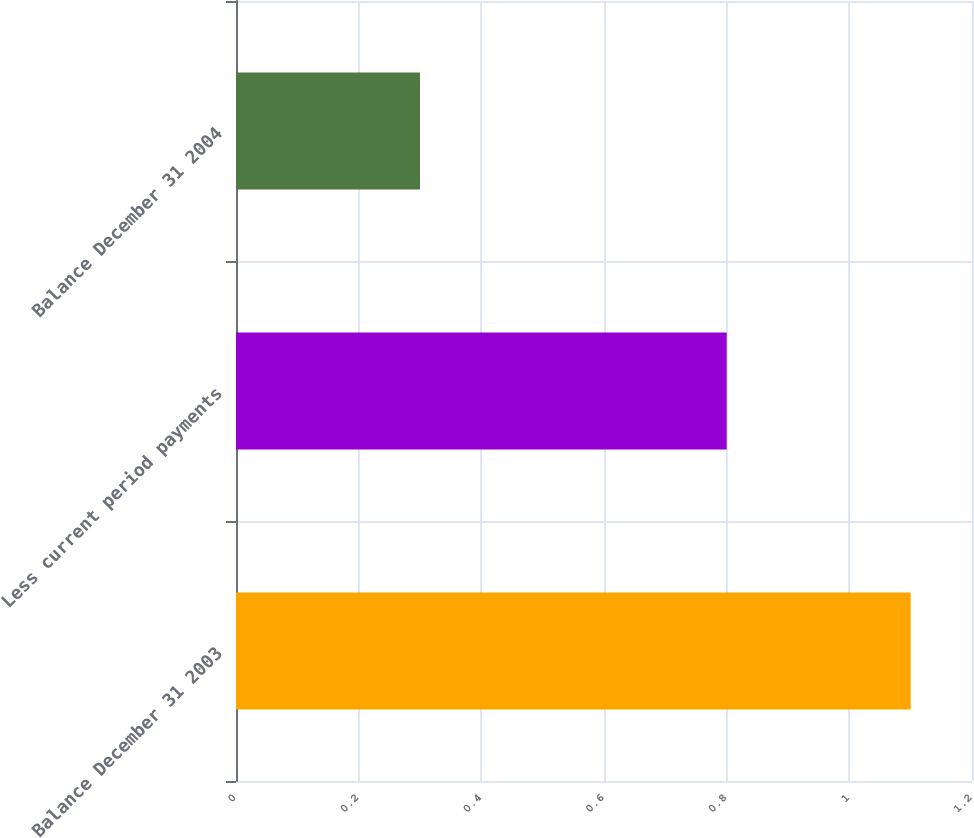Convert chart to OTSL. <chart><loc_0><loc_0><loc_500><loc_500><bar_chart><fcel>Balance December 31 2003<fcel>Less current period payments<fcel>Balance December 31 2004<nl><fcel>1.1<fcel>0.8<fcel>0.3<nl></chart> 